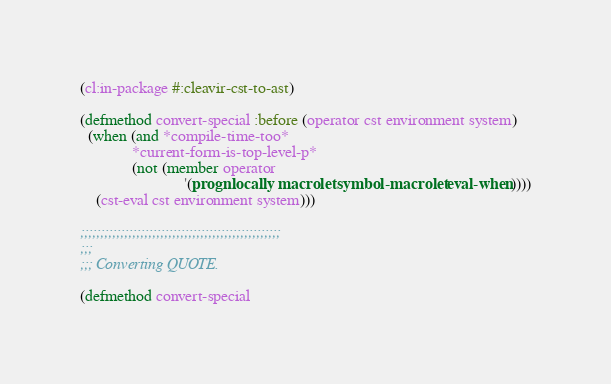<code> <loc_0><loc_0><loc_500><loc_500><_Lisp_>(cl:in-package #:cleavir-cst-to-ast)

(defmethod convert-special :before (operator cst environment system)
  (when (and *compile-time-too*
             *current-form-is-top-level-p*
             (not (member operator
                          '(progn locally macrolet symbol-macrolet eval-when))))
    (cst-eval cst environment system)))

;;;;;;;;;;;;;;;;;;;;;;;;;;;;;;;;;;;;;;;;;;;;;;;;;;
;;;
;;; Converting QUOTE.

(defmethod convert-special</code> 